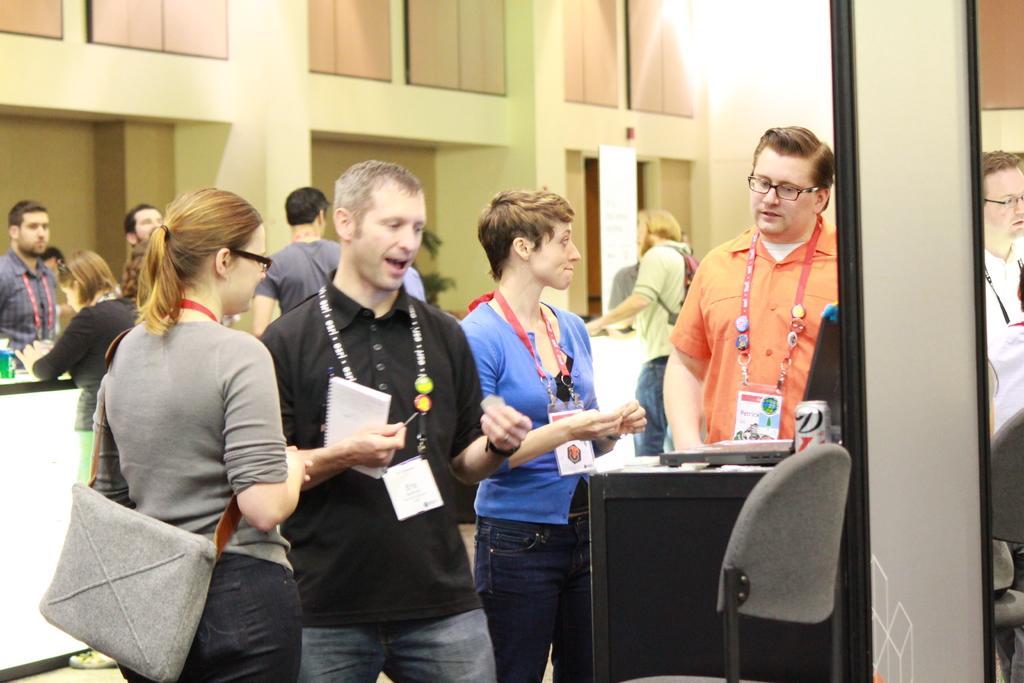In one or two sentences, can you explain what this image depicts? In this image there are group of persons standing. In the front there is a woman standing and wearing a bag which is grey in colour and there is a person standing wearing a t-shirt which is black in colour and holding a paper in his hand and in the background there are cupboards on the wall and in the front on the right side there is an object which is black in colour and there is an empty chair. 